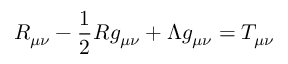<formula> <loc_0><loc_0><loc_500><loc_500>R _ { \mu \nu } - { \frac { 1 } { 2 } } R g _ { \mu \nu } + \Lambda g _ { \mu \nu } = T _ { \mu \nu }</formula> 